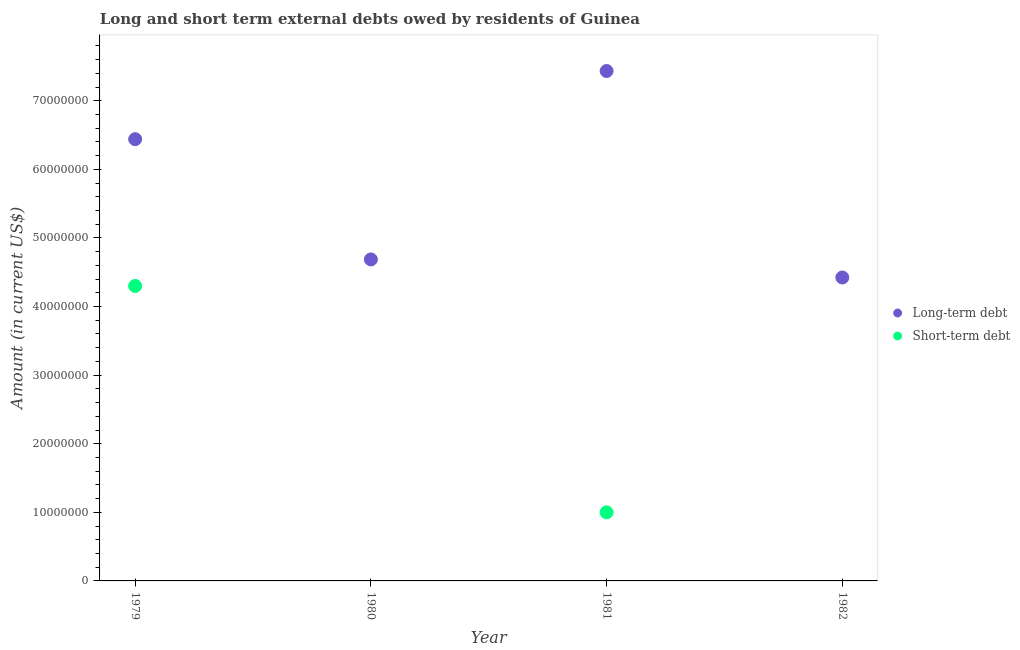How many different coloured dotlines are there?
Your response must be concise. 2. Is the number of dotlines equal to the number of legend labels?
Ensure brevity in your answer.  No. What is the short-term debts owed by residents in 1980?
Make the answer very short. 0. Across all years, what is the maximum long-term debts owed by residents?
Your answer should be very brief. 7.43e+07. What is the total short-term debts owed by residents in the graph?
Your response must be concise. 5.30e+07. What is the difference between the long-term debts owed by residents in 1979 and that in 1982?
Provide a short and direct response. 2.02e+07. What is the difference between the short-term debts owed by residents in 1979 and the long-term debts owed by residents in 1981?
Keep it short and to the point. -3.13e+07. What is the average long-term debts owed by residents per year?
Your answer should be very brief. 5.75e+07. In the year 1979, what is the difference between the long-term debts owed by residents and short-term debts owed by residents?
Ensure brevity in your answer.  2.14e+07. What is the ratio of the long-term debts owed by residents in 1980 to that in 1981?
Your response must be concise. 0.63. Is the difference between the long-term debts owed by residents in 1979 and 1981 greater than the difference between the short-term debts owed by residents in 1979 and 1981?
Give a very brief answer. No. What is the difference between the highest and the second highest long-term debts owed by residents?
Provide a short and direct response. 9.94e+06. What is the difference between the highest and the lowest long-term debts owed by residents?
Your response must be concise. 3.01e+07. In how many years, is the long-term debts owed by residents greater than the average long-term debts owed by residents taken over all years?
Provide a short and direct response. 2. Is the sum of the long-term debts owed by residents in 1979 and 1981 greater than the maximum short-term debts owed by residents across all years?
Provide a short and direct response. Yes. Does the short-term debts owed by residents monotonically increase over the years?
Provide a short and direct response. No. How many dotlines are there?
Provide a succinct answer. 2. How many legend labels are there?
Your answer should be very brief. 2. How are the legend labels stacked?
Your response must be concise. Vertical. What is the title of the graph?
Your response must be concise. Long and short term external debts owed by residents of Guinea. What is the label or title of the Y-axis?
Offer a very short reply. Amount (in current US$). What is the Amount (in current US$) of Long-term debt in 1979?
Offer a terse response. 6.44e+07. What is the Amount (in current US$) of Short-term debt in 1979?
Provide a succinct answer. 4.30e+07. What is the Amount (in current US$) in Long-term debt in 1980?
Your response must be concise. 4.69e+07. What is the Amount (in current US$) in Long-term debt in 1981?
Your answer should be compact. 7.43e+07. What is the Amount (in current US$) in Long-term debt in 1982?
Ensure brevity in your answer.  4.42e+07. What is the Amount (in current US$) in Short-term debt in 1982?
Your answer should be compact. 0. Across all years, what is the maximum Amount (in current US$) in Long-term debt?
Ensure brevity in your answer.  7.43e+07. Across all years, what is the maximum Amount (in current US$) of Short-term debt?
Your answer should be very brief. 4.30e+07. Across all years, what is the minimum Amount (in current US$) of Long-term debt?
Provide a short and direct response. 4.42e+07. Across all years, what is the minimum Amount (in current US$) of Short-term debt?
Ensure brevity in your answer.  0. What is the total Amount (in current US$) of Long-term debt in the graph?
Provide a short and direct response. 2.30e+08. What is the total Amount (in current US$) of Short-term debt in the graph?
Offer a very short reply. 5.30e+07. What is the difference between the Amount (in current US$) in Long-term debt in 1979 and that in 1980?
Offer a terse response. 1.75e+07. What is the difference between the Amount (in current US$) in Long-term debt in 1979 and that in 1981?
Keep it short and to the point. -9.94e+06. What is the difference between the Amount (in current US$) of Short-term debt in 1979 and that in 1981?
Provide a succinct answer. 3.30e+07. What is the difference between the Amount (in current US$) in Long-term debt in 1979 and that in 1982?
Offer a terse response. 2.02e+07. What is the difference between the Amount (in current US$) of Long-term debt in 1980 and that in 1981?
Offer a terse response. -2.75e+07. What is the difference between the Amount (in current US$) of Long-term debt in 1980 and that in 1982?
Offer a very short reply. 2.63e+06. What is the difference between the Amount (in current US$) in Long-term debt in 1981 and that in 1982?
Provide a short and direct response. 3.01e+07. What is the difference between the Amount (in current US$) of Long-term debt in 1979 and the Amount (in current US$) of Short-term debt in 1981?
Give a very brief answer. 5.44e+07. What is the difference between the Amount (in current US$) in Long-term debt in 1980 and the Amount (in current US$) in Short-term debt in 1981?
Your answer should be very brief. 3.69e+07. What is the average Amount (in current US$) in Long-term debt per year?
Your answer should be compact. 5.75e+07. What is the average Amount (in current US$) in Short-term debt per year?
Your answer should be compact. 1.32e+07. In the year 1979, what is the difference between the Amount (in current US$) in Long-term debt and Amount (in current US$) in Short-term debt?
Offer a terse response. 2.14e+07. In the year 1981, what is the difference between the Amount (in current US$) of Long-term debt and Amount (in current US$) of Short-term debt?
Your response must be concise. 6.43e+07. What is the ratio of the Amount (in current US$) in Long-term debt in 1979 to that in 1980?
Ensure brevity in your answer.  1.37. What is the ratio of the Amount (in current US$) in Long-term debt in 1979 to that in 1981?
Your response must be concise. 0.87. What is the ratio of the Amount (in current US$) in Short-term debt in 1979 to that in 1981?
Ensure brevity in your answer.  4.3. What is the ratio of the Amount (in current US$) in Long-term debt in 1979 to that in 1982?
Your answer should be compact. 1.46. What is the ratio of the Amount (in current US$) in Long-term debt in 1980 to that in 1981?
Keep it short and to the point. 0.63. What is the ratio of the Amount (in current US$) of Long-term debt in 1980 to that in 1982?
Provide a short and direct response. 1.06. What is the ratio of the Amount (in current US$) in Long-term debt in 1981 to that in 1982?
Offer a terse response. 1.68. What is the difference between the highest and the second highest Amount (in current US$) in Long-term debt?
Provide a succinct answer. 9.94e+06. What is the difference between the highest and the lowest Amount (in current US$) in Long-term debt?
Your answer should be very brief. 3.01e+07. What is the difference between the highest and the lowest Amount (in current US$) in Short-term debt?
Offer a terse response. 4.30e+07. 